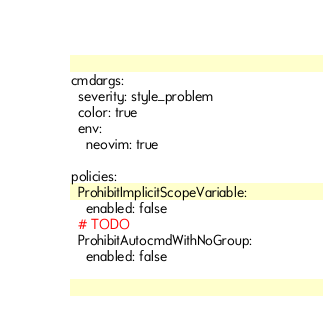<code> <loc_0><loc_0><loc_500><loc_500><_YAML_>cmdargs:
  severity: style_problem
  color: true
  env:
    neovim: true

policies:
  ProhibitImplicitScopeVariable:
    enabled: false
  # TODO
  ProhibitAutocmdWithNoGroup:
    enabled: false
</code> 